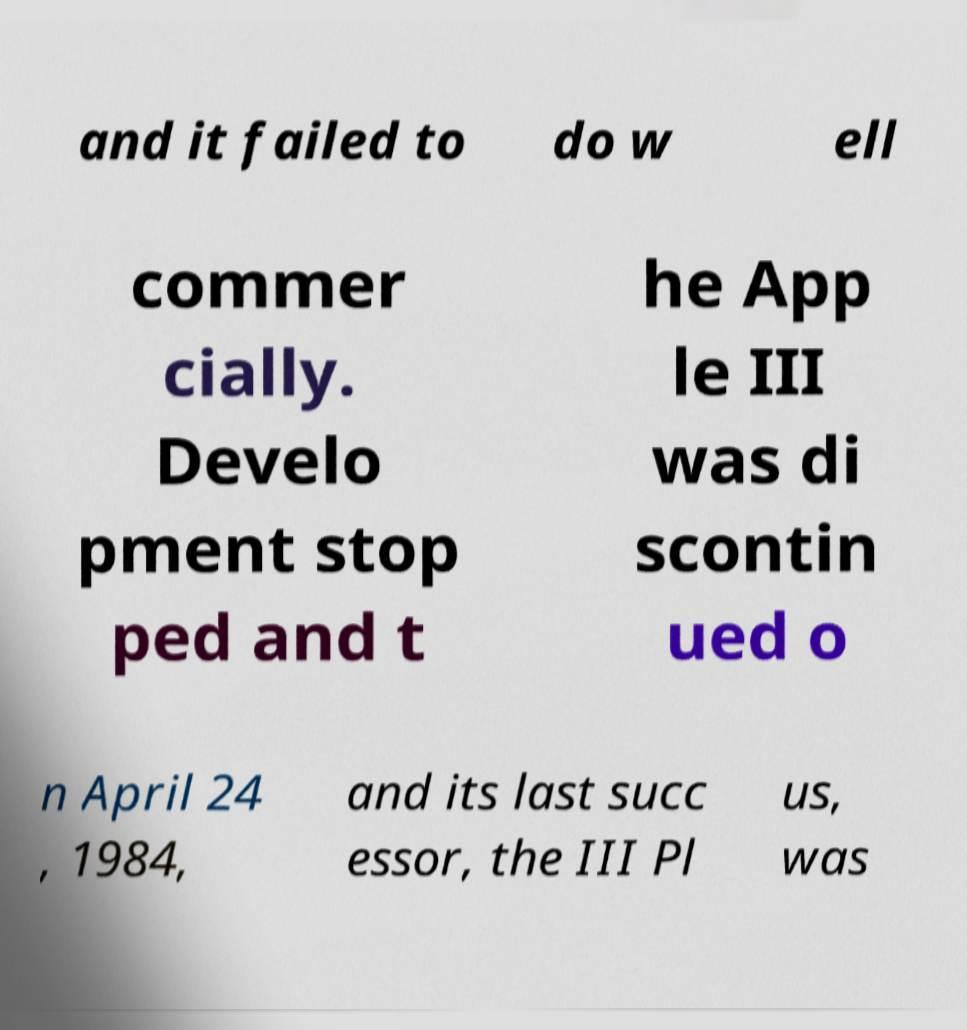What messages or text are displayed in this image? I need them in a readable, typed format. and it failed to do w ell commer cially. Develo pment stop ped and t he App le III was di scontin ued o n April 24 , 1984, and its last succ essor, the III Pl us, was 